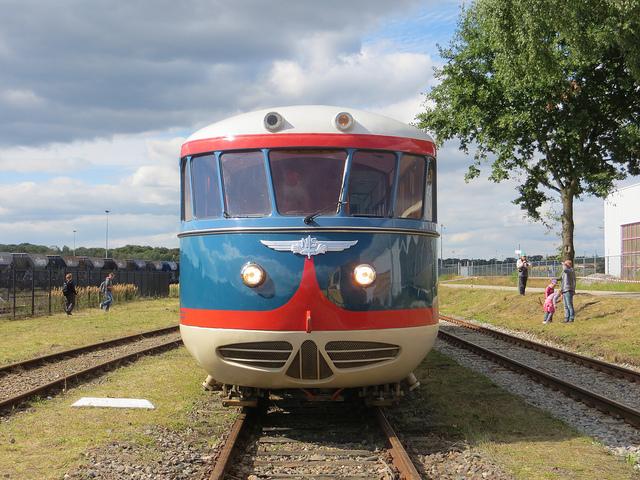How many lights on the train?
Be succinct. 2. How many people are standing by the tree?
Be succinct. 3. How many tracks are in the photo?
Be succinct. 3. 